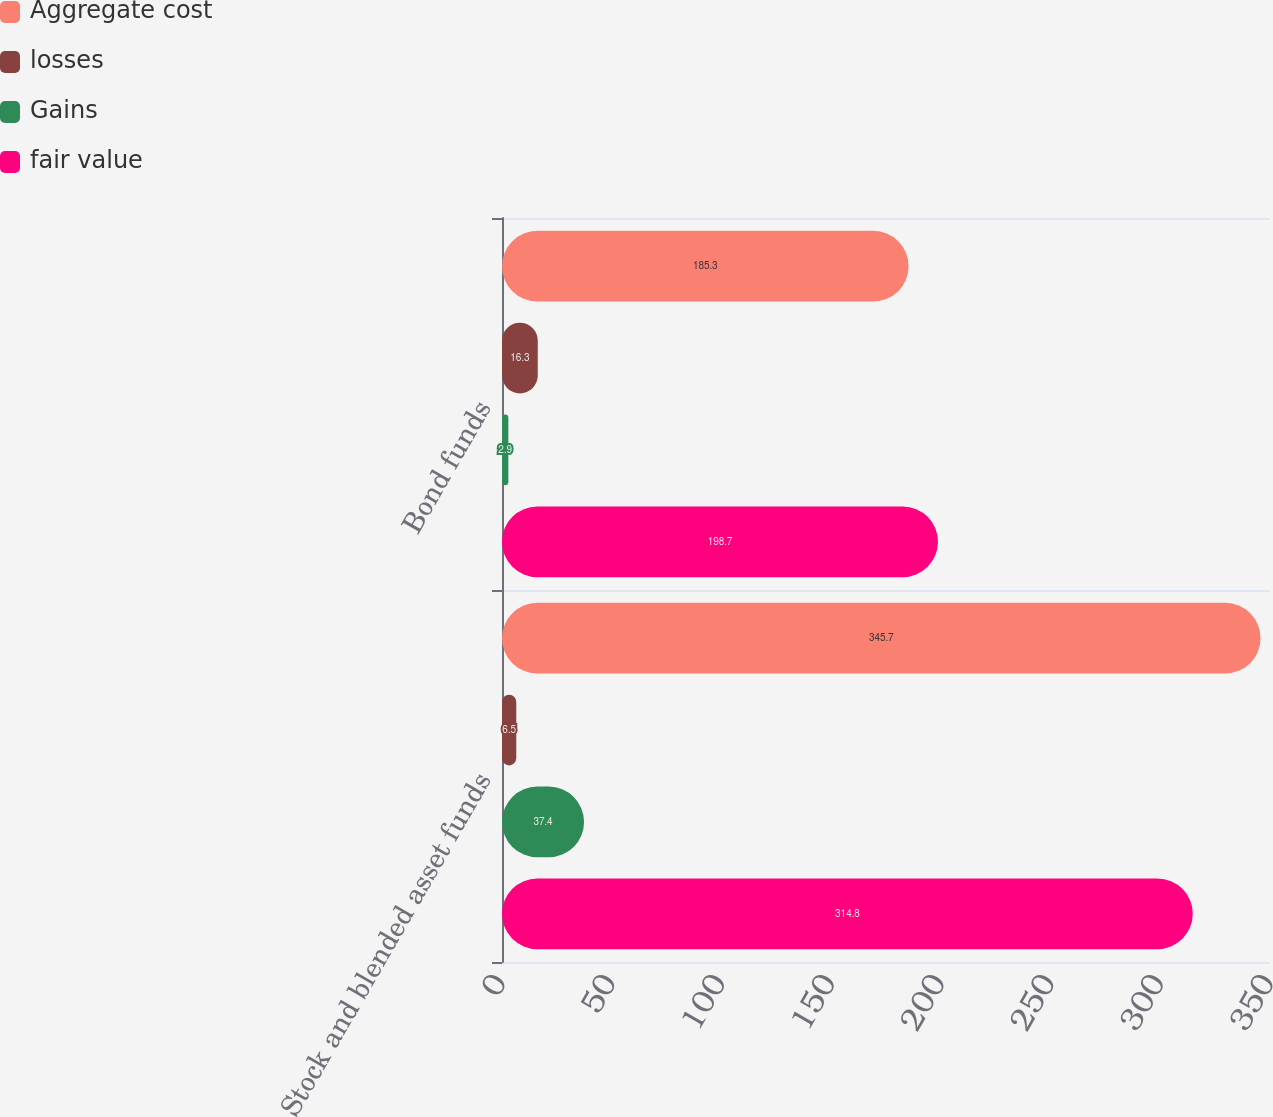Convert chart to OTSL. <chart><loc_0><loc_0><loc_500><loc_500><stacked_bar_chart><ecel><fcel>Stock and blended asset funds<fcel>Bond funds<nl><fcel>Aggregate cost<fcel>345.7<fcel>185.3<nl><fcel>losses<fcel>6.5<fcel>16.3<nl><fcel>Gains<fcel>37.4<fcel>2.9<nl><fcel>fair value<fcel>314.8<fcel>198.7<nl></chart> 